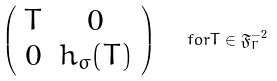Convert formula to latex. <formula><loc_0><loc_0><loc_500><loc_500>\left ( \begin{array} { c c } T & 0 \\ 0 & h _ { \sigma } ( T ) \end{array} \right ) \quad f o r T \in \mathfrak { F } _ { \Gamma } ^ { - 2 }</formula> 